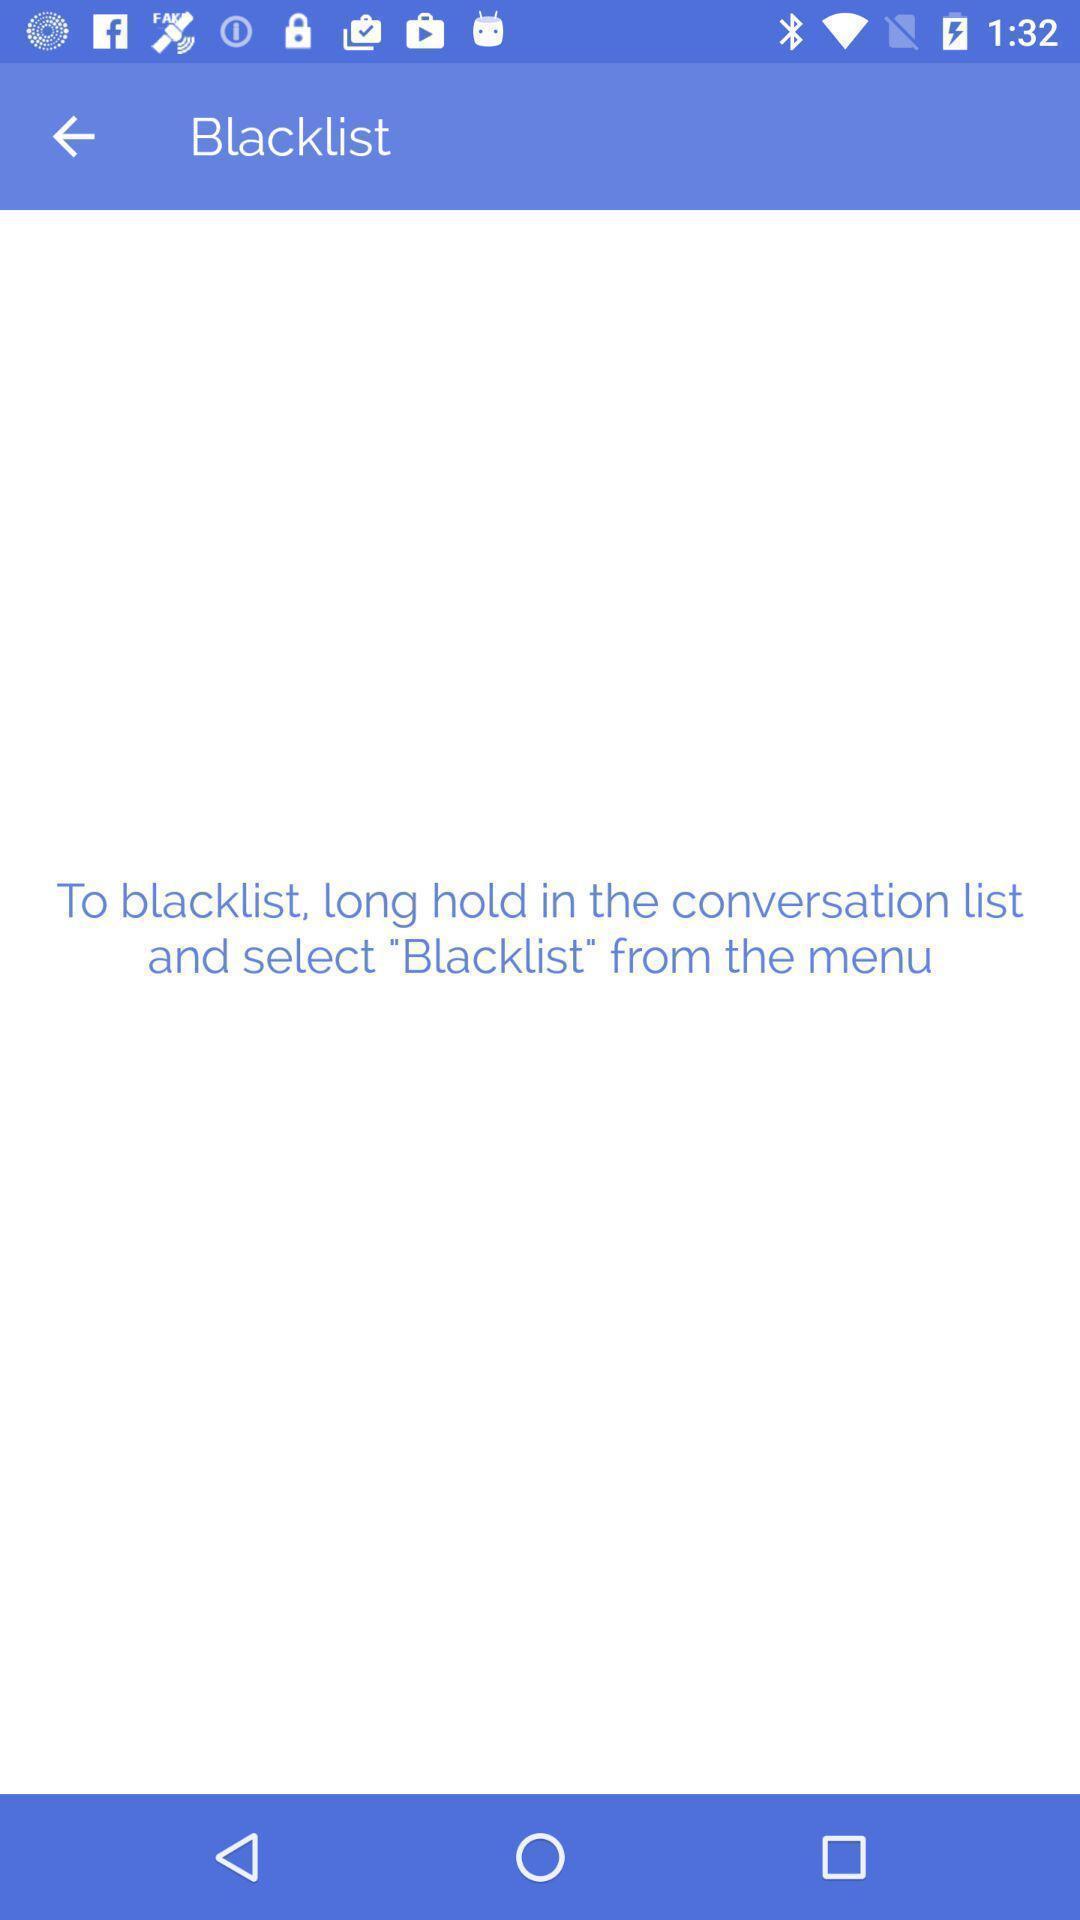Describe the visual elements of this screenshot. Screen displaying the black list page. 